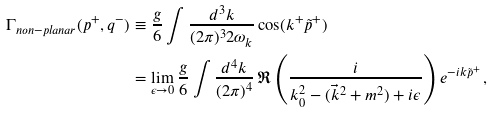<formula> <loc_0><loc_0><loc_500><loc_500>\Gamma _ { n o n - p l a n a r } ( p ^ { + } , q ^ { - } ) & \equiv \frac { g } { 6 } \int \frac { d ^ { 3 } k } { ( 2 \pi ) ^ { 3 } 2 \omega _ { k } } \cos ( k ^ { + } \tilde { p } ^ { + } ) \\ & = \lim _ { \epsilon \to 0 } \frac { g } { 6 } \int \frac { d ^ { 4 } k } { ( 2 \pi ) ^ { 4 } } \, \Re \left ( \frac { i } { k ^ { 2 } _ { 0 } - ( \vec { k } ^ { 2 } + m ^ { 2 } ) + i \epsilon } \right ) e ^ { - i k \tilde { p } ^ { + } } \, ,</formula> 